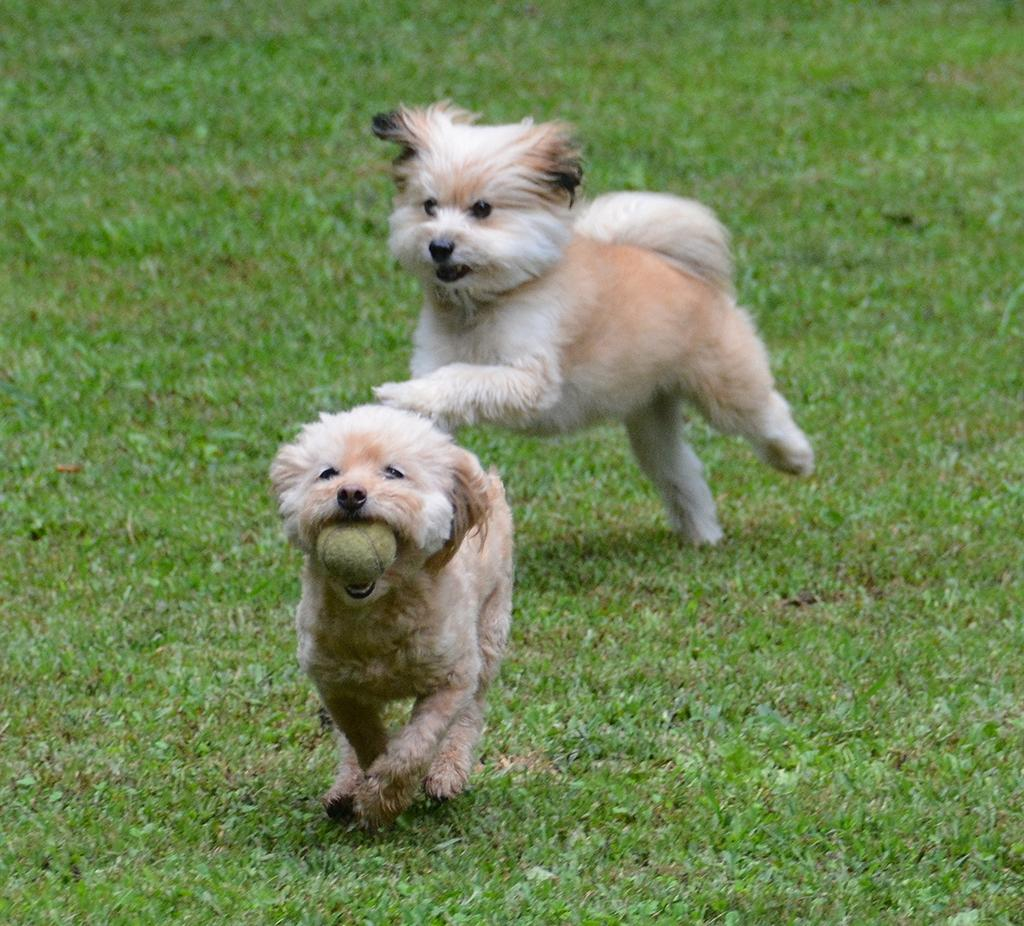How many puppies are in the image? There are two puppies in the image. What are the puppies doing in the image? The puppies are running in the image. Can you describe what one of the puppies is holding in its mouth? One of the puppies has a ball in its mouth. What type of surface can be seen in the background of the image? There is ground visible in the background of the image. What type of ticket can be seen in the image? There is no ticket present in the image; it features two puppies running and one holding a ball. Can you describe the sound of the thunder in the image? There is no thunder present in the image; it is a scene of two puppies running and one holding a ball. 